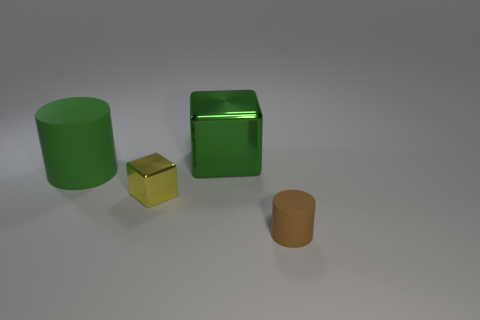How many small things are green cubes or cylinders?
Offer a very short reply. 1. Is there anything else that is the same color as the big rubber cylinder?
Your answer should be compact. Yes. What is the shape of the thing that is made of the same material as the brown cylinder?
Your answer should be very brief. Cylinder. What is the size of the rubber cylinder behind the tiny brown rubber thing?
Provide a succinct answer. Large. The big metal object is what shape?
Your answer should be compact. Cube. There is a green thing right of the big green rubber thing; does it have the same size as the matte object that is on the right side of the small yellow metal object?
Offer a very short reply. No. There is a metal block on the right side of the cube that is in front of the matte thing behind the small cylinder; what is its size?
Your answer should be compact. Large. What is the shape of the big object that is on the left side of the shiny thing that is on the left side of the shiny object that is behind the big cylinder?
Offer a terse response. Cylinder. The tiny object on the left side of the small brown matte cylinder has what shape?
Make the answer very short. Cube. Do the large green cylinder and the cube that is to the right of the small yellow object have the same material?
Provide a succinct answer. No. 